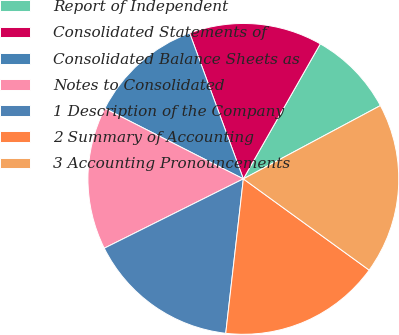Convert chart. <chart><loc_0><loc_0><loc_500><loc_500><pie_chart><fcel>Report of Independent<fcel>Consolidated Statements of<fcel>Consolidated Balance Sheets as<fcel>Notes to Consolidated<fcel>1 Description of the Company<fcel>2 Summary of Accounting<fcel>3 Accounting Pronouncements<nl><fcel>8.94%<fcel>13.86%<fcel>11.89%<fcel>14.85%<fcel>15.83%<fcel>16.82%<fcel>17.8%<nl></chart> 